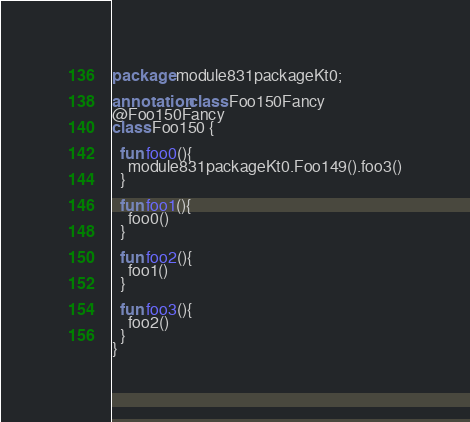<code> <loc_0><loc_0><loc_500><loc_500><_Kotlin_>package module831packageKt0;

annotation class Foo150Fancy
@Foo150Fancy
class Foo150 {

  fun foo0(){
    module831packageKt0.Foo149().foo3()
  }

  fun foo1(){
    foo0()
  }

  fun foo2(){
    foo1()
  }

  fun foo3(){
    foo2()
  }
}</code> 